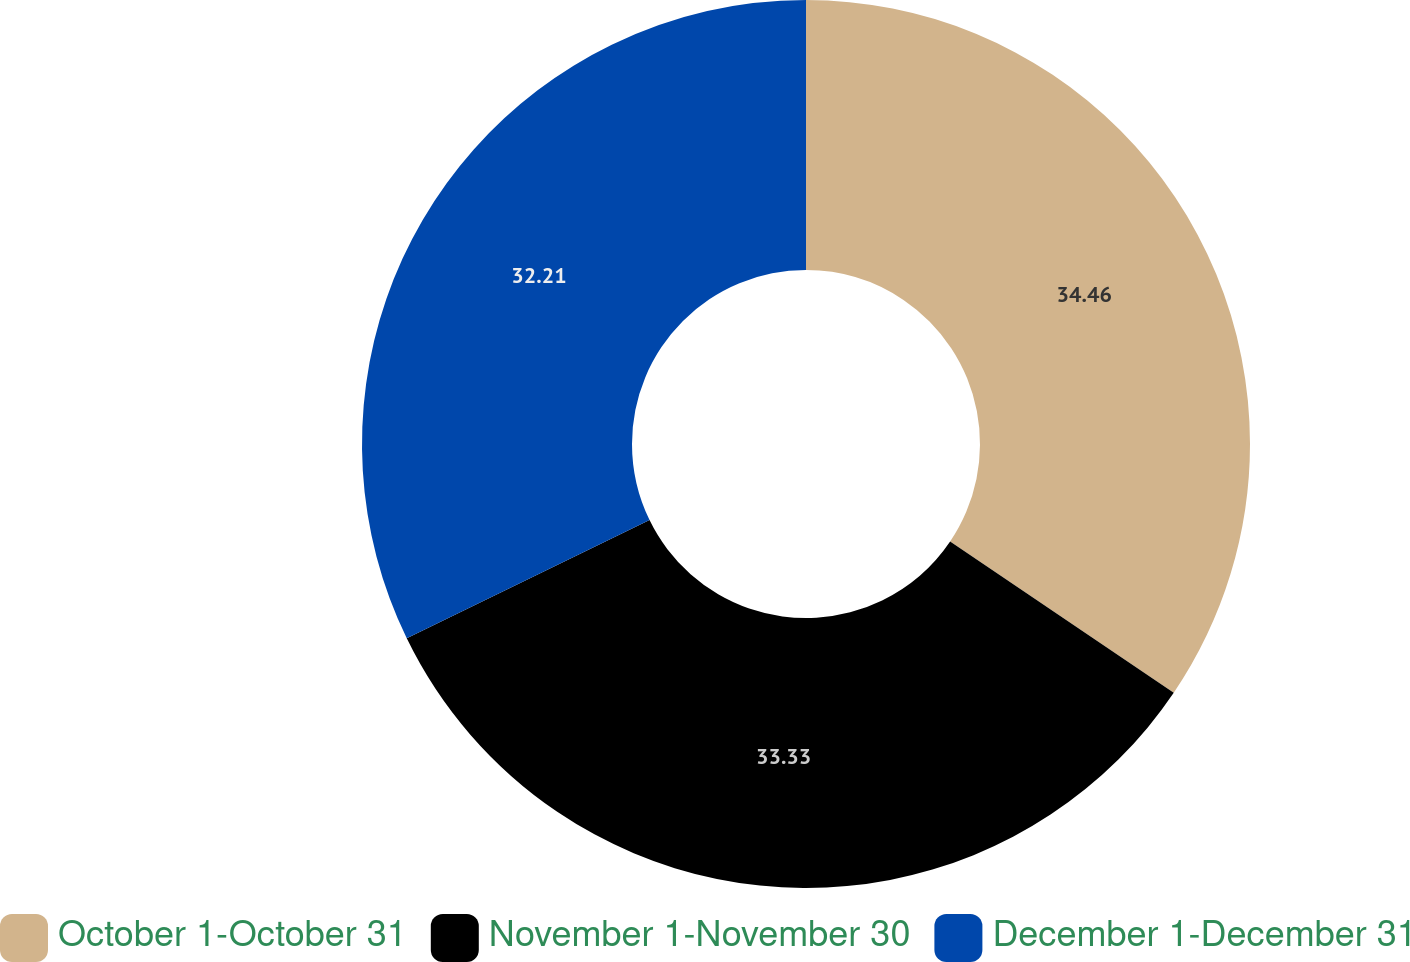<chart> <loc_0><loc_0><loc_500><loc_500><pie_chart><fcel>October 1-October 31<fcel>November 1-November 30<fcel>December 1-December 31<nl><fcel>34.47%<fcel>33.33%<fcel>32.21%<nl></chart> 